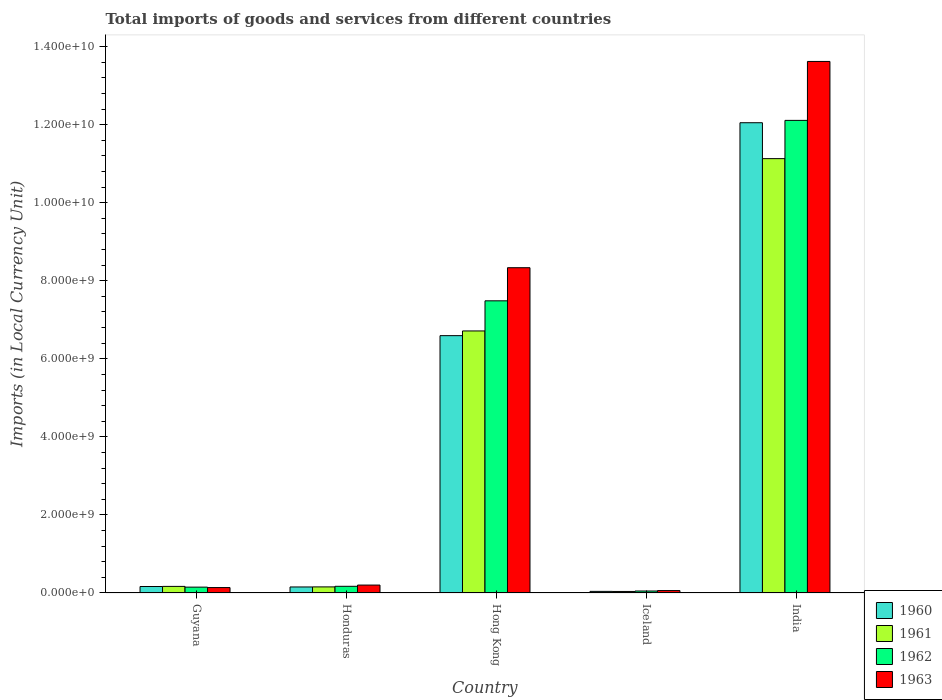How many different coloured bars are there?
Ensure brevity in your answer.  4. Are the number of bars on each tick of the X-axis equal?
Offer a very short reply. Yes. What is the label of the 1st group of bars from the left?
Your answer should be compact. Guyana. In how many cases, is the number of bars for a given country not equal to the number of legend labels?
Your answer should be compact. 0. What is the Amount of goods and services imports in 1961 in India?
Offer a terse response. 1.11e+1. Across all countries, what is the maximum Amount of goods and services imports in 1961?
Your answer should be compact. 1.11e+1. Across all countries, what is the minimum Amount of goods and services imports in 1961?
Give a very brief answer. 3.90e+07. In which country was the Amount of goods and services imports in 1963 maximum?
Your answer should be very brief. India. What is the total Amount of goods and services imports in 1961 in the graph?
Ensure brevity in your answer.  1.82e+1. What is the difference between the Amount of goods and services imports in 1960 in Honduras and that in India?
Your answer should be compact. -1.19e+1. What is the difference between the Amount of goods and services imports in 1963 in Iceland and the Amount of goods and services imports in 1962 in Honduras?
Make the answer very short. -1.09e+08. What is the average Amount of goods and services imports in 1963 per country?
Provide a short and direct response. 4.47e+09. What is the difference between the Amount of goods and services imports of/in 1961 and Amount of goods and services imports of/in 1962 in India?
Your answer should be very brief. -9.80e+08. In how many countries, is the Amount of goods and services imports in 1961 greater than 11600000000 LCU?
Offer a very short reply. 0. What is the ratio of the Amount of goods and services imports in 1963 in Guyana to that in Iceland?
Your response must be concise. 2.24. Is the difference between the Amount of goods and services imports in 1961 in Hong Kong and India greater than the difference between the Amount of goods and services imports in 1962 in Hong Kong and India?
Keep it short and to the point. Yes. What is the difference between the highest and the second highest Amount of goods and services imports in 1963?
Your answer should be compact. 5.28e+09. What is the difference between the highest and the lowest Amount of goods and services imports in 1962?
Offer a very short reply. 1.21e+1. In how many countries, is the Amount of goods and services imports in 1962 greater than the average Amount of goods and services imports in 1962 taken over all countries?
Offer a very short reply. 2. Is it the case that in every country, the sum of the Amount of goods and services imports in 1960 and Amount of goods and services imports in 1962 is greater than the sum of Amount of goods and services imports in 1961 and Amount of goods and services imports in 1963?
Give a very brief answer. No. How many bars are there?
Provide a short and direct response. 20. Are all the bars in the graph horizontal?
Offer a very short reply. No. How many countries are there in the graph?
Give a very brief answer. 5. What is the difference between two consecutive major ticks on the Y-axis?
Provide a succinct answer. 2.00e+09. Does the graph contain any zero values?
Keep it short and to the point. No. Does the graph contain grids?
Keep it short and to the point. No. How many legend labels are there?
Make the answer very short. 4. How are the legend labels stacked?
Provide a succinct answer. Vertical. What is the title of the graph?
Give a very brief answer. Total imports of goods and services from different countries. Does "1999" appear as one of the legend labels in the graph?
Offer a terse response. No. What is the label or title of the X-axis?
Ensure brevity in your answer.  Country. What is the label or title of the Y-axis?
Ensure brevity in your answer.  Imports (in Local Currency Unit). What is the Imports (in Local Currency Unit) in 1960 in Guyana?
Ensure brevity in your answer.  1.66e+08. What is the Imports (in Local Currency Unit) of 1961 in Guyana?
Give a very brief answer. 1.69e+08. What is the Imports (in Local Currency Unit) in 1962 in Guyana?
Offer a terse response. 1.50e+08. What is the Imports (in Local Currency Unit) in 1963 in Guyana?
Offer a very short reply. 1.39e+08. What is the Imports (in Local Currency Unit) in 1960 in Honduras?
Your response must be concise. 1.55e+08. What is the Imports (in Local Currency Unit) in 1961 in Honduras?
Your answer should be compact. 1.56e+08. What is the Imports (in Local Currency Unit) of 1962 in Honduras?
Provide a succinct answer. 1.71e+08. What is the Imports (in Local Currency Unit) of 1963 in Honduras?
Your response must be concise. 2.03e+08. What is the Imports (in Local Currency Unit) of 1960 in Hong Kong?
Your answer should be compact. 6.59e+09. What is the Imports (in Local Currency Unit) in 1961 in Hong Kong?
Provide a succinct answer. 6.71e+09. What is the Imports (in Local Currency Unit) in 1962 in Hong Kong?
Ensure brevity in your answer.  7.49e+09. What is the Imports (in Local Currency Unit) of 1963 in Hong Kong?
Provide a short and direct response. 8.34e+09. What is the Imports (in Local Currency Unit) in 1960 in Iceland?
Provide a short and direct response. 4.10e+07. What is the Imports (in Local Currency Unit) in 1961 in Iceland?
Ensure brevity in your answer.  3.90e+07. What is the Imports (in Local Currency Unit) in 1962 in Iceland?
Offer a terse response. 5.09e+07. What is the Imports (in Local Currency Unit) of 1963 in Iceland?
Your answer should be compact. 6.19e+07. What is the Imports (in Local Currency Unit) of 1960 in India?
Offer a very short reply. 1.20e+1. What is the Imports (in Local Currency Unit) of 1961 in India?
Offer a terse response. 1.11e+1. What is the Imports (in Local Currency Unit) of 1962 in India?
Offer a terse response. 1.21e+1. What is the Imports (in Local Currency Unit) in 1963 in India?
Your answer should be compact. 1.36e+1. Across all countries, what is the maximum Imports (in Local Currency Unit) in 1960?
Offer a terse response. 1.20e+1. Across all countries, what is the maximum Imports (in Local Currency Unit) in 1961?
Your answer should be very brief. 1.11e+1. Across all countries, what is the maximum Imports (in Local Currency Unit) of 1962?
Offer a terse response. 1.21e+1. Across all countries, what is the maximum Imports (in Local Currency Unit) of 1963?
Offer a very short reply. 1.36e+1. Across all countries, what is the minimum Imports (in Local Currency Unit) of 1960?
Your response must be concise. 4.10e+07. Across all countries, what is the minimum Imports (in Local Currency Unit) in 1961?
Ensure brevity in your answer.  3.90e+07. Across all countries, what is the minimum Imports (in Local Currency Unit) of 1962?
Your answer should be very brief. 5.09e+07. Across all countries, what is the minimum Imports (in Local Currency Unit) of 1963?
Keep it short and to the point. 6.19e+07. What is the total Imports (in Local Currency Unit) in 1960 in the graph?
Offer a terse response. 1.90e+1. What is the total Imports (in Local Currency Unit) of 1961 in the graph?
Your response must be concise. 1.82e+1. What is the total Imports (in Local Currency Unit) of 1962 in the graph?
Your answer should be compact. 2.00e+1. What is the total Imports (in Local Currency Unit) in 1963 in the graph?
Make the answer very short. 2.24e+1. What is the difference between the Imports (in Local Currency Unit) in 1960 in Guyana and that in Honduras?
Keep it short and to the point. 1.16e+07. What is the difference between the Imports (in Local Currency Unit) in 1961 in Guyana and that in Honduras?
Provide a short and direct response. 1.26e+07. What is the difference between the Imports (in Local Currency Unit) of 1962 in Guyana and that in Honduras?
Offer a very short reply. -2.12e+07. What is the difference between the Imports (in Local Currency Unit) of 1963 in Guyana and that in Honduras?
Provide a short and direct response. -6.38e+07. What is the difference between the Imports (in Local Currency Unit) in 1960 in Guyana and that in Hong Kong?
Offer a very short reply. -6.43e+09. What is the difference between the Imports (in Local Currency Unit) in 1961 in Guyana and that in Hong Kong?
Your answer should be compact. -6.55e+09. What is the difference between the Imports (in Local Currency Unit) in 1962 in Guyana and that in Hong Kong?
Your response must be concise. -7.34e+09. What is the difference between the Imports (in Local Currency Unit) in 1963 in Guyana and that in Hong Kong?
Your answer should be compact. -8.20e+09. What is the difference between the Imports (in Local Currency Unit) in 1960 in Guyana and that in Iceland?
Give a very brief answer. 1.25e+08. What is the difference between the Imports (in Local Currency Unit) of 1961 in Guyana and that in Iceland?
Offer a terse response. 1.30e+08. What is the difference between the Imports (in Local Currency Unit) in 1962 in Guyana and that in Iceland?
Provide a short and direct response. 9.91e+07. What is the difference between the Imports (in Local Currency Unit) in 1963 in Guyana and that in Iceland?
Give a very brief answer. 7.71e+07. What is the difference between the Imports (in Local Currency Unit) in 1960 in Guyana and that in India?
Ensure brevity in your answer.  -1.19e+1. What is the difference between the Imports (in Local Currency Unit) of 1961 in Guyana and that in India?
Your answer should be very brief. -1.10e+1. What is the difference between the Imports (in Local Currency Unit) in 1962 in Guyana and that in India?
Offer a very short reply. -1.20e+1. What is the difference between the Imports (in Local Currency Unit) of 1963 in Guyana and that in India?
Ensure brevity in your answer.  -1.35e+1. What is the difference between the Imports (in Local Currency Unit) in 1960 in Honduras and that in Hong Kong?
Offer a very short reply. -6.44e+09. What is the difference between the Imports (in Local Currency Unit) in 1961 in Honduras and that in Hong Kong?
Offer a very short reply. -6.56e+09. What is the difference between the Imports (in Local Currency Unit) of 1962 in Honduras and that in Hong Kong?
Make the answer very short. -7.32e+09. What is the difference between the Imports (in Local Currency Unit) of 1963 in Honduras and that in Hong Kong?
Make the answer very short. -8.13e+09. What is the difference between the Imports (in Local Currency Unit) of 1960 in Honduras and that in Iceland?
Offer a very short reply. 1.14e+08. What is the difference between the Imports (in Local Currency Unit) in 1961 in Honduras and that in Iceland?
Your answer should be very brief. 1.17e+08. What is the difference between the Imports (in Local Currency Unit) in 1962 in Honduras and that in Iceland?
Offer a terse response. 1.20e+08. What is the difference between the Imports (in Local Currency Unit) of 1963 in Honduras and that in Iceland?
Your response must be concise. 1.41e+08. What is the difference between the Imports (in Local Currency Unit) of 1960 in Honduras and that in India?
Give a very brief answer. -1.19e+1. What is the difference between the Imports (in Local Currency Unit) of 1961 in Honduras and that in India?
Offer a very short reply. -1.10e+1. What is the difference between the Imports (in Local Currency Unit) in 1962 in Honduras and that in India?
Offer a terse response. -1.19e+1. What is the difference between the Imports (in Local Currency Unit) of 1963 in Honduras and that in India?
Make the answer very short. -1.34e+1. What is the difference between the Imports (in Local Currency Unit) in 1960 in Hong Kong and that in Iceland?
Offer a very short reply. 6.55e+09. What is the difference between the Imports (in Local Currency Unit) in 1961 in Hong Kong and that in Iceland?
Ensure brevity in your answer.  6.68e+09. What is the difference between the Imports (in Local Currency Unit) in 1962 in Hong Kong and that in Iceland?
Provide a short and direct response. 7.44e+09. What is the difference between the Imports (in Local Currency Unit) of 1963 in Hong Kong and that in Iceland?
Offer a terse response. 8.27e+09. What is the difference between the Imports (in Local Currency Unit) of 1960 in Hong Kong and that in India?
Keep it short and to the point. -5.46e+09. What is the difference between the Imports (in Local Currency Unit) of 1961 in Hong Kong and that in India?
Your answer should be very brief. -4.42e+09. What is the difference between the Imports (in Local Currency Unit) of 1962 in Hong Kong and that in India?
Give a very brief answer. -4.62e+09. What is the difference between the Imports (in Local Currency Unit) of 1963 in Hong Kong and that in India?
Offer a terse response. -5.28e+09. What is the difference between the Imports (in Local Currency Unit) of 1960 in Iceland and that in India?
Offer a terse response. -1.20e+1. What is the difference between the Imports (in Local Currency Unit) of 1961 in Iceland and that in India?
Offer a very short reply. -1.11e+1. What is the difference between the Imports (in Local Currency Unit) of 1962 in Iceland and that in India?
Your response must be concise. -1.21e+1. What is the difference between the Imports (in Local Currency Unit) of 1963 in Iceland and that in India?
Your answer should be very brief. -1.36e+1. What is the difference between the Imports (in Local Currency Unit) in 1960 in Guyana and the Imports (in Local Currency Unit) in 1961 in Honduras?
Give a very brief answer. 1.00e+07. What is the difference between the Imports (in Local Currency Unit) in 1960 in Guyana and the Imports (in Local Currency Unit) in 1962 in Honduras?
Offer a terse response. -5.00e+06. What is the difference between the Imports (in Local Currency Unit) in 1960 in Guyana and the Imports (in Local Currency Unit) in 1963 in Honduras?
Give a very brief answer. -3.66e+07. What is the difference between the Imports (in Local Currency Unit) in 1961 in Guyana and the Imports (in Local Currency Unit) in 1962 in Honduras?
Offer a terse response. -2.40e+06. What is the difference between the Imports (in Local Currency Unit) in 1961 in Guyana and the Imports (in Local Currency Unit) in 1963 in Honduras?
Keep it short and to the point. -3.40e+07. What is the difference between the Imports (in Local Currency Unit) in 1962 in Guyana and the Imports (in Local Currency Unit) in 1963 in Honduras?
Keep it short and to the point. -5.28e+07. What is the difference between the Imports (in Local Currency Unit) of 1960 in Guyana and the Imports (in Local Currency Unit) of 1961 in Hong Kong?
Your answer should be compact. -6.55e+09. What is the difference between the Imports (in Local Currency Unit) in 1960 in Guyana and the Imports (in Local Currency Unit) in 1962 in Hong Kong?
Your answer should be compact. -7.32e+09. What is the difference between the Imports (in Local Currency Unit) in 1960 in Guyana and the Imports (in Local Currency Unit) in 1963 in Hong Kong?
Your response must be concise. -8.17e+09. What is the difference between the Imports (in Local Currency Unit) of 1961 in Guyana and the Imports (in Local Currency Unit) of 1962 in Hong Kong?
Make the answer very short. -7.32e+09. What is the difference between the Imports (in Local Currency Unit) of 1961 in Guyana and the Imports (in Local Currency Unit) of 1963 in Hong Kong?
Keep it short and to the point. -8.17e+09. What is the difference between the Imports (in Local Currency Unit) in 1962 in Guyana and the Imports (in Local Currency Unit) in 1963 in Hong Kong?
Your response must be concise. -8.19e+09. What is the difference between the Imports (in Local Currency Unit) in 1960 in Guyana and the Imports (in Local Currency Unit) in 1961 in Iceland?
Provide a short and direct response. 1.27e+08. What is the difference between the Imports (in Local Currency Unit) of 1960 in Guyana and the Imports (in Local Currency Unit) of 1962 in Iceland?
Your response must be concise. 1.15e+08. What is the difference between the Imports (in Local Currency Unit) of 1960 in Guyana and the Imports (in Local Currency Unit) of 1963 in Iceland?
Your answer should be compact. 1.04e+08. What is the difference between the Imports (in Local Currency Unit) in 1961 in Guyana and the Imports (in Local Currency Unit) in 1962 in Iceland?
Make the answer very short. 1.18e+08. What is the difference between the Imports (in Local Currency Unit) of 1961 in Guyana and the Imports (in Local Currency Unit) of 1963 in Iceland?
Give a very brief answer. 1.07e+08. What is the difference between the Imports (in Local Currency Unit) in 1962 in Guyana and the Imports (in Local Currency Unit) in 1963 in Iceland?
Provide a short and direct response. 8.81e+07. What is the difference between the Imports (in Local Currency Unit) of 1960 in Guyana and the Imports (in Local Currency Unit) of 1961 in India?
Keep it short and to the point. -1.10e+1. What is the difference between the Imports (in Local Currency Unit) of 1960 in Guyana and the Imports (in Local Currency Unit) of 1962 in India?
Make the answer very short. -1.19e+1. What is the difference between the Imports (in Local Currency Unit) in 1960 in Guyana and the Imports (in Local Currency Unit) in 1963 in India?
Offer a very short reply. -1.35e+1. What is the difference between the Imports (in Local Currency Unit) of 1961 in Guyana and the Imports (in Local Currency Unit) of 1962 in India?
Provide a succinct answer. -1.19e+1. What is the difference between the Imports (in Local Currency Unit) in 1961 in Guyana and the Imports (in Local Currency Unit) in 1963 in India?
Your answer should be very brief. -1.35e+1. What is the difference between the Imports (in Local Currency Unit) of 1962 in Guyana and the Imports (in Local Currency Unit) of 1963 in India?
Make the answer very short. -1.35e+1. What is the difference between the Imports (in Local Currency Unit) in 1960 in Honduras and the Imports (in Local Currency Unit) in 1961 in Hong Kong?
Your response must be concise. -6.56e+09. What is the difference between the Imports (in Local Currency Unit) of 1960 in Honduras and the Imports (in Local Currency Unit) of 1962 in Hong Kong?
Make the answer very short. -7.33e+09. What is the difference between the Imports (in Local Currency Unit) in 1960 in Honduras and the Imports (in Local Currency Unit) in 1963 in Hong Kong?
Your response must be concise. -8.18e+09. What is the difference between the Imports (in Local Currency Unit) of 1961 in Honduras and the Imports (in Local Currency Unit) of 1962 in Hong Kong?
Make the answer very short. -7.33e+09. What is the difference between the Imports (in Local Currency Unit) of 1961 in Honduras and the Imports (in Local Currency Unit) of 1963 in Hong Kong?
Keep it short and to the point. -8.18e+09. What is the difference between the Imports (in Local Currency Unit) in 1962 in Honduras and the Imports (in Local Currency Unit) in 1963 in Hong Kong?
Give a very brief answer. -8.16e+09. What is the difference between the Imports (in Local Currency Unit) of 1960 in Honduras and the Imports (in Local Currency Unit) of 1961 in Iceland?
Offer a terse response. 1.16e+08. What is the difference between the Imports (in Local Currency Unit) of 1960 in Honduras and the Imports (in Local Currency Unit) of 1962 in Iceland?
Offer a terse response. 1.04e+08. What is the difference between the Imports (in Local Currency Unit) of 1960 in Honduras and the Imports (in Local Currency Unit) of 1963 in Iceland?
Provide a succinct answer. 9.27e+07. What is the difference between the Imports (in Local Currency Unit) of 1961 in Honduras and the Imports (in Local Currency Unit) of 1962 in Iceland?
Offer a very short reply. 1.05e+08. What is the difference between the Imports (in Local Currency Unit) of 1961 in Honduras and the Imports (in Local Currency Unit) of 1963 in Iceland?
Keep it short and to the point. 9.43e+07. What is the difference between the Imports (in Local Currency Unit) in 1962 in Honduras and the Imports (in Local Currency Unit) in 1963 in Iceland?
Ensure brevity in your answer.  1.09e+08. What is the difference between the Imports (in Local Currency Unit) in 1960 in Honduras and the Imports (in Local Currency Unit) in 1961 in India?
Your answer should be very brief. -1.10e+1. What is the difference between the Imports (in Local Currency Unit) in 1960 in Honduras and the Imports (in Local Currency Unit) in 1962 in India?
Provide a succinct answer. -1.20e+1. What is the difference between the Imports (in Local Currency Unit) of 1960 in Honduras and the Imports (in Local Currency Unit) of 1963 in India?
Your answer should be very brief. -1.35e+1. What is the difference between the Imports (in Local Currency Unit) of 1961 in Honduras and the Imports (in Local Currency Unit) of 1962 in India?
Your answer should be compact. -1.20e+1. What is the difference between the Imports (in Local Currency Unit) of 1961 in Honduras and the Imports (in Local Currency Unit) of 1963 in India?
Ensure brevity in your answer.  -1.35e+1. What is the difference between the Imports (in Local Currency Unit) of 1962 in Honduras and the Imports (in Local Currency Unit) of 1963 in India?
Make the answer very short. -1.34e+1. What is the difference between the Imports (in Local Currency Unit) of 1960 in Hong Kong and the Imports (in Local Currency Unit) of 1961 in Iceland?
Give a very brief answer. 6.56e+09. What is the difference between the Imports (in Local Currency Unit) of 1960 in Hong Kong and the Imports (in Local Currency Unit) of 1962 in Iceland?
Keep it short and to the point. 6.54e+09. What is the difference between the Imports (in Local Currency Unit) in 1960 in Hong Kong and the Imports (in Local Currency Unit) in 1963 in Iceland?
Make the answer very short. 6.53e+09. What is the difference between the Imports (in Local Currency Unit) in 1961 in Hong Kong and the Imports (in Local Currency Unit) in 1962 in Iceland?
Your response must be concise. 6.66e+09. What is the difference between the Imports (in Local Currency Unit) in 1961 in Hong Kong and the Imports (in Local Currency Unit) in 1963 in Iceland?
Ensure brevity in your answer.  6.65e+09. What is the difference between the Imports (in Local Currency Unit) of 1962 in Hong Kong and the Imports (in Local Currency Unit) of 1963 in Iceland?
Give a very brief answer. 7.42e+09. What is the difference between the Imports (in Local Currency Unit) in 1960 in Hong Kong and the Imports (in Local Currency Unit) in 1961 in India?
Ensure brevity in your answer.  -4.54e+09. What is the difference between the Imports (in Local Currency Unit) of 1960 in Hong Kong and the Imports (in Local Currency Unit) of 1962 in India?
Keep it short and to the point. -5.52e+09. What is the difference between the Imports (in Local Currency Unit) of 1960 in Hong Kong and the Imports (in Local Currency Unit) of 1963 in India?
Make the answer very short. -7.03e+09. What is the difference between the Imports (in Local Currency Unit) in 1961 in Hong Kong and the Imports (in Local Currency Unit) in 1962 in India?
Ensure brevity in your answer.  -5.40e+09. What is the difference between the Imports (in Local Currency Unit) of 1961 in Hong Kong and the Imports (in Local Currency Unit) of 1963 in India?
Keep it short and to the point. -6.91e+09. What is the difference between the Imports (in Local Currency Unit) in 1962 in Hong Kong and the Imports (in Local Currency Unit) in 1963 in India?
Keep it short and to the point. -6.13e+09. What is the difference between the Imports (in Local Currency Unit) in 1960 in Iceland and the Imports (in Local Currency Unit) in 1961 in India?
Make the answer very short. -1.11e+1. What is the difference between the Imports (in Local Currency Unit) in 1960 in Iceland and the Imports (in Local Currency Unit) in 1962 in India?
Make the answer very short. -1.21e+1. What is the difference between the Imports (in Local Currency Unit) of 1960 in Iceland and the Imports (in Local Currency Unit) of 1963 in India?
Provide a short and direct response. -1.36e+1. What is the difference between the Imports (in Local Currency Unit) of 1961 in Iceland and the Imports (in Local Currency Unit) of 1962 in India?
Your answer should be compact. -1.21e+1. What is the difference between the Imports (in Local Currency Unit) in 1961 in Iceland and the Imports (in Local Currency Unit) in 1963 in India?
Offer a terse response. -1.36e+1. What is the difference between the Imports (in Local Currency Unit) in 1962 in Iceland and the Imports (in Local Currency Unit) in 1963 in India?
Keep it short and to the point. -1.36e+1. What is the average Imports (in Local Currency Unit) of 1960 per country?
Ensure brevity in your answer.  3.80e+09. What is the average Imports (in Local Currency Unit) in 1961 per country?
Make the answer very short. 3.64e+09. What is the average Imports (in Local Currency Unit) of 1962 per country?
Provide a short and direct response. 3.99e+09. What is the average Imports (in Local Currency Unit) in 1963 per country?
Provide a succinct answer. 4.47e+09. What is the difference between the Imports (in Local Currency Unit) of 1960 and Imports (in Local Currency Unit) of 1961 in Guyana?
Keep it short and to the point. -2.60e+06. What is the difference between the Imports (in Local Currency Unit) in 1960 and Imports (in Local Currency Unit) in 1962 in Guyana?
Provide a short and direct response. 1.62e+07. What is the difference between the Imports (in Local Currency Unit) in 1960 and Imports (in Local Currency Unit) in 1963 in Guyana?
Provide a succinct answer. 2.72e+07. What is the difference between the Imports (in Local Currency Unit) in 1961 and Imports (in Local Currency Unit) in 1962 in Guyana?
Your answer should be compact. 1.88e+07. What is the difference between the Imports (in Local Currency Unit) of 1961 and Imports (in Local Currency Unit) of 1963 in Guyana?
Your response must be concise. 2.98e+07. What is the difference between the Imports (in Local Currency Unit) in 1962 and Imports (in Local Currency Unit) in 1963 in Guyana?
Ensure brevity in your answer.  1.10e+07. What is the difference between the Imports (in Local Currency Unit) of 1960 and Imports (in Local Currency Unit) of 1961 in Honduras?
Keep it short and to the point. -1.60e+06. What is the difference between the Imports (in Local Currency Unit) of 1960 and Imports (in Local Currency Unit) of 1962 in Honduras?
Ensure brevity in your answer.  -1.66e+07. What is the difference between the Imports (in Local Currency Unit) of 1960 and Imports (in Local Currency Unit) of 1963 in Honduras?
Make the answer very short. -4.82e+07. What is the difference between the Imports (in Local Currency Unit) in 1961 and Imports (in Local Currency Unit) in 1962 in Honduras?
Provide a short and direct response. -1.50e+07. What is the difference between the Imports (in Local Currency Unit) in 1961 and Imports (in Local Currency Unit) in 1963 in Honduras?
Your answer should be compact. -4.66e+07. What is the difference between the Imports (in Local Currency Unit) in 1962 and Imports (in Local Currency Unit) in 1963 in Honduras?
Your answer should be very brief. -3.16e+07. What is the difference between the Imports (in Local Currency Unit) of 1960 and Imports (in Local Currency Unit) of 1961 in Hong Kong?
Provide a succinct answer. -1.20e+08. What is the difference between the Imports (in Local Currency Unit) of 1960 and Imports (in Local Currency Unit) of 1962 in Hong Kong?
Make the answer very short. -8.92e+08. What is the difference between the Imports (in Local Currency Unit) in 1960 and Imports (in Local Currency Unit) in 1963 in Hong Kong?
Make the answer very short. -1.74e+09. What is the difference between the Imports (in Local Currency Unit) in 1961 and Imports (in Local Currency Unit) in 1962 in Hong Kong?
Provide a short and direct response. -7.72e+08. What is the difference between the Imports (in Local Currency Unit) of 1961 and Imports (in Local Currency Unit) of 1963 in Hong Kong?
Provide a succinct answer. -1.62e+09. What is the difference between the Imports (in Local Currency Unit) in 1962 and Imports (in Local Currency Unit) in 1963 in Hong Kong?
Your answer should be very brief. -8.49e+08. What is the difference between the Imports (in Local Currency Unit) in 1960 and Imports (in Local Currency Unit) in 1961 in Iceland?
Offer a very short reply. 2.00e+06. What is the difference between the Imports (in Local Currency Unit) of 1960 and Imports (in Local Currency Unit) of 1962 in Iceland?
Provide a short and direct response. -9.99e+06. What is the difference between the Imports (in Local Currency Unit) of 1960 and Imports (in Local Currency Unit) of 1963 in Iceland?
Your response must be concise. -2.10e+07. What is the difference between the Imports (in Local Currency Unit) of 1961 and Imports (in Local Currency Unit) of 1962 in Iceland?
Ensure brevity in your answer.  -1.20e+07. What is the difference between the Imports (in Local Currency Unit) in 1961 and Imports (in Local Currency Unit) in 1963 in Iceland?
Provide a succinct answer. -2.30e+07. What is the difference between the Imports (in Local Currency Unit) in 1962 and Imports (in Local Currency Unit) in 1963 in Iceland?
Your response must be concise. -1.10e+07. What is the difference between the Imports (in Local Currency Unit) in 1960 and Imports (in Local Currency Unit) in 1961 in India?
Provide a short and direct response. 9.20e+08. What is the difference between the Imports (in Local Currency Unit) in 1960 and Imports (in Local Currency Unit) in 1962 in India?
Offer a very short reply. -6.00e+07. What is the difference between the Imports (in Local Currency Unit) in 1960 and Imports (in Local Currency Unit) in 1963 in India?
Ensure brevity in your answer.  -1.57e+09. What is the difference between the Imports (in Local Currency Unit) of 1961 and Imports (in Local Currency Unit) of 1962 in India?
Provide a short and direct response. -9.80e+08. What is the difference between the Imports (in Local Currency Unit) of 1961 and Imports (in Local Currency Unit) of 1963 in India?
Provide a succinct answer. -2.49e+09. What is the difference between the Imports (in Local Currency Unit) of 1962 and Imports (in Local Currency Unit) of 1963 in India?
Keep it short and to the point. -1.51e+09. What is the ratio of the Imports (in Local Currency Unit) in 1960 in Guyana to that in Honduras?
Ensure brevity in your answer.  1.07. What is the ratio of the Imports (in Local Currency Unit) of 1961 in Guyana to that in Honduras?
Ensure brevity in your answer.  1.08. What is the ratio of the Imports (in Local Currency Unit) of 1962 in Guyana to that in Honduras?
Offer a terse response. 0.88. What is the ratio of the Imports (in Local Currency Unit) in 1963 in Guyana to that in Honduras?
Your response must be concise. 0.69. What is the ratio of the Imports (in Local Currency Unit) in 1960 in Guyana to that in Hong Kong?
Your response must be concise. 0.03. What is the ratio of the Imports (in Local Currency Unit) of 1961 in Guyana to that in Hong Kong?
Keep it short and to the point. 0.03. What is the ratio of the Imports (in Local Currency Unit) in 1962 in Guyana to that in Hong Kong?
Your answer should be compact. 0.02. What is the ratio of the Imports (in Local Currency Unit) of 1963 in Guyana to that in Hong Kong?
Your answer should be very brief. 0.02. What is the ratio of the Imports (in Local Currency Unit) in 1960 in Guyana to that in Iceland?
Keep it short and to the point. 4.06. What is the ratio of the Imports (in Local Currency Unit) of 1961 in Guyana to that in Iceland?
Ensure brevity in your answer.  4.33. What is the ratio of the Imports (in Local Currency Unit) of 1962 in Guyana to that in Iceland?
Provide a succinct answer. 2.94. What is the ratio of the Imports (in Local Currency Unit) in 1963 in Guyana to that in Iceland?
Offer a very short reply. 2.24. What is the ratio of the Imports (in Local Currency Unit) of 1960 in Guyana to that in India?
Offer a terse response. 0.01. What is the ratio of the Imports (in Local Currency Unit) in 1961 in Guyana to that in India?
Your answer should be very brief. 0.02. What is the ratio of the Imports (in Local Currency Unit) in 1962 in Guyana to that in India?
Your response must be concise. 0.01. What is the ratio of the Imports (in Local Currency Unit) of 1963 in Guyana to that in India?
Your answer should be very brief. 0.01. What is the ratio of the Imports (in Local Currency Unit) in 1960 in Honduras to that in Hong Kong?
Your answer should be very brief. 0.02. What is the ratio of the Imports (in Local Currency Unit) of 1961 in Honduras to that in Hong Kong?
Provide a succinct answer. 0.02. What is the ratio of the Imports (in Local Currency Unit) of 1962 in Honduras to that in Hong Kong?
Make the answer very short. 0.02. What is the ratio of the Imports (in Local Currency Unit) of 1963 in Honduras to that in Hong Kong?
Ensure brevity in your answer.  0.02. What is the ratio of the Imports (in Local Currency Unit) of 1960 in Honduras to that in Iceland?
Your answer should be very brief. 3.77. What is the ratio of the Imports (in Local Currency Unit) in 1961 in Honduras to that in Iceland?
Ensure brevity in your answer.  4.01. What is the ratio of the Imports (in Local Currency Unit) of 1962 in Honduras to that in Iceland?
Offer a terse response. 3.36. What is the ratio of the Imports (in Local Currency Unit) of 1963 in Honduras to that in Iceland?
Provide a short and direct response. 3.27. What is the ratio of the Imports (in Local Currency Unit) in 1960 in Honduras to that in India?
Provide a succinct answer. 0.01. What is the ratio of the Imports (in Local Currency Unit) of 1961 in Honduras to that in India?
Provide a succinct answer. 0.01. What is the ratio of the Imports (in Local Currency Unit) of 1962 in Honduras to that in India?
Keep it short and to the point. 0.01. What is the ratio of the Imports (in Local Currency Unit) of 1963 in Honduras to that in India?
Your answer should be compact. 0.01. What is the ratio of the Imports (in Local Currency Unit) of 1960 in Hong Kong to that in Iceland?
Provide a succinct answer. 161. What is the ratio of the Imports (in Local Currency Unit) of 1961 in Hong Kong to that in Iceland?
Give a very brief answer. 172.35. What is the ratio of the Imports (in Local Currency Unit) in 1962 in Hong Kong to that in Iceland?
Provide a succinct answer. 146.95. What is the ratio of the Imports (in Local Currency Unit) of 1963 in Hong Kong to that in Iceland?
Give a very brief answer. 134.58. What is the ratio of the Imports (in Local Currency Unit) in 1960 in Hong Kong to that in India?
Give a very brief answer. 0.55. What is the ratio of the Imports (in Local Currency Unit) in 1961 in Hong Kong to that in India?
Your answer should be very brief. 0.6. What is the ratio of the Imports (in Local Currency Unit) of 1962 in Hong Kong to that in India?
Keep it short and to the point. 0.62. What is the ratio of the Imports (in Local Currency Unit) in 1963 in Hong Kong to that in India?
Ensure brevity in your answer.  0.61. What is the ratio of the Imports (in Local Currency Unit) in 1960 in Iceland to that in India?
Give a very brief answer. 0. What is the ratio of the Imports (in Local Currency Unit) of 1961 in Iceland to that in India?
Make the answer very short. 0. What is the ratio of the Imports (in Local Currency Unit) in 1962 in Iceland to that in India?
Keep it short and to the point. 0. What is the ratio of the Imports (in Local Currency Unit) in 1963 in Iceland to that in India?
Provide a short and direct response. 0. What is the difference between the highest and the second highest Imports (in Local Currency Unit) in 1960?
Ensure brevity in your answer.  5.46e+09. What is the difference between the highest and the second highest Imports (in Local Currency Unit) in 1961?
Offer a terse response. 4.42e+09. What is the difference between the highest and the second highest Imports (in Local Currency Unit) of 1962?
Provide a short and direct response. 4.62e+09. What is the difference between the highest and the second highest Imports (in Local Currency Unit) in 1963?
Provide a short and direct response. 5.28e+09. What is the difference between the highest and the lowest Imports (in Local Currency Unit) of 1960?
Keep it short and to the point. 1.20e+1. What is the difference between the highest and the lowest Imports (in Local Currency Unit) of 1961?
Offer a terse response. 1.11e+1. What is the difference between the highest and the lowest Imports (in Local Currency Unit) of 1962?
Offer a very short reply. 1.21e+1. What is the difference between the highest and the lowest Imports (in Local Currency Unit) in 1963?
Ensure brevity in your answer.  1.36e+1. 